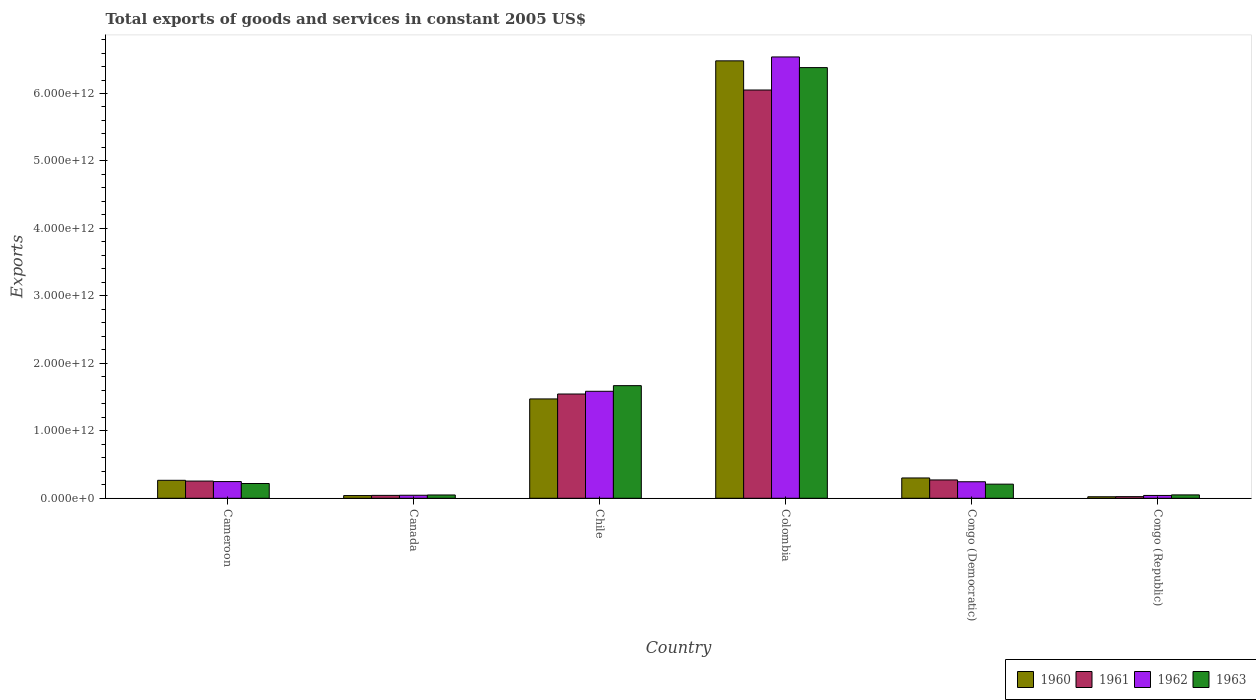Are the number of bars per tick equal to the number of legend labels?
Your answer should be compact. Yes. How many bars are there on the 4th tick from the left?
Keep it short and to the point. 4. What is the label of the 5th group of bars from the left?
Your answer should be very brief. Congo (Democratic). What is the total exports of goods and services in 1963 in Congo (Democratic)?
Offer a very short reply. 2.09e+11. Across all countries, what is the maximum total exports of goods and services in 1961?
Give a very brief answer. 6.05e+12. Across all countries, what is the minimum total exports of goods and services in 1962?
Offer a very short reply. 4.20e+1. In which country was the total exports of goods and services in 1961 minimum?
Keep it short and to the point. Congo (Republic). What is the total total exports of goods and services in 1962 in the graph?
Your response must be concise. 8.71e+12. What is the difference between the total exports of goods and services in 1962 in Cameroon and that in Chile?
Ensure brevity in your answer.  -1.34e+12. What is the difference between the total exports of goods and services in 1960 in Congo (Democratic) and the total exports of goods and services in 1962 in Cameroon?
Make the answer very short. 5.34e+1. What is the average total exports of goods and services in 1960 per country?
Keep it short and to the point. 1.43e+12. What is the difference between the total exports of goods and services of/in 1963 and total exports of goods and services of/in 1960 in Cameroon?
Give a very brief answer. -4.75e+1. What is the ratio of the total exports of goods and services in 1961 in Cameroon to that in Colombia?
Give a very brief answer. 0.04. Is the difference between the total exports of goods and services in 1963 in Cameroon and Congo (Republic) greater than the difference between the total exports of goods and services in 1960 in Cameroon and Congo (Republic)?
Make the answer very short. No. What is the difference between the highest and the second highest total exports of goods and services in 1960?
Keep it short and to the point. 6.18e+12. What is the difference between the highest and the lowest total exports of goods and services in 1962?
Make the answer very short. 6.50e+12. Is the sum of the total exports of goods and services in 1963 in Chile and Congo (Republic) greater than the maximum total exports of goods and services in 1962 across all countries?
Your answer should be very brief. No. Is it the case that in every country, the sum of the total exports of goods and services in 1962 and total exports of goods and services in 1960 is greater than the sum of total exports of goods and services in 1961 and total exports of goods and services in 1963?
Give a very brief answer. No. What does the 1st bar from the left in Cameroon represents?
Your response must be concise. 1960. Is it the case that in every country, the sum of the total exports of goods and services in 1962 and total exports of goods and services in 1960 is greater than the total exports of goods and services in 1963?
Ensure brevity in your answer.  Yes. How many bars are there?
Ensure brevity in your answer.  24. What is the difference between two consecutive major ticks on the Y-axis?
Provide a short and direct response. 1.00e+12. Are the values on the major ticks of Y-axis written in scientific E-notation?
Offer a terse response. Yes. Does the graph contain grids?
Provide a short and direct response. No. How many legend labels are there?
Your answer should be compact. 4. How are the legend labels stacked?
Offer a terse response. Horizontal. What is the title of the graph?
Offer a terse response. Total exports of goods and services in constant 2005 US$. What is the label or title of the X-axis?
Your answer should be compact. Country. What is the label or title of the Y-axis?
Ensure brevity in your answer.  Exports. What is the Exports in 1960 in Cameroon?
Your answer should be compact. 2.66e+11. What is the Exports of 1961 in Cameroon?
Your answer should be very brief. 2.55e+11. What is the Exports of 1962 in Cameroon?
Provide a short and direct response. 2.48e+11. What is the Exports in 1963 in Cameroon?
Give a very brief answer. 2.19e+11. What is the Exports of 1960 in Canada?
Keep it short and to the point. 4.02e+1. What is the Exports in 1961 in Canada?
Your response must be concise. 4.29e+1. What is the Exports of 1962 in Canada?
Offer a very short reply. 4.49e+1. What is the Exports in 1963 in Canada?
Give a very brief answer. 4.91e+1. What is the Exports of 1960 in Chile?
Give a very brief answer. 1.47e+12. What is the Exports of 1961 in Chile?
Keep it short and to the point. 1.55e+12. What is the Exports in 1962 in Chile?
Offer a very short reply. 1.59e+12. What is the Exports in 1963 in Chile?
Your answer should be very brief. 1.67e+12. What is the Exports of 1960 in Colombia?
Your answer should be compact. 6.48e+12. What is the Exports of 1961 in Colombia?
Make the answer very short. 6.05e+12. What is the Exports of 1962 in Colombia?
Offer a very short reply. 6.54e+12. What is the Exports of 1963 in Colombia?
Make the answer very short. 6.38e+12. What is the Exports of 1960 in Congo (Democratic)?
Give a very brief answer. 3.01e+11. What is the Exports of 1961 in Congo (Democratic)?
Provide a short and direct response. 2.72e+11. What is the Exports in 1962 in Congo (Democratic)?
Provide a short and direct response. 2.45e+11. What is the Exports of 1963 in Congo (Democratic)?
Ensure brevity in your answer.  2.09e+11. What is the Exports of 1960 in Congo (Republic)?
Provide a succinct answer. 2.25e+1. What is the Exports of 1961 in Congo (Republic)?
Your response must be concise. 2.42e+1. What is the Exports of 1962 in Congo (Republic)?
Keep it short and to the point. 4.20e+1. What is the Exports of 1963 in Congo (Republic)?
Ensure brevity in your answer.  5.01e+1. Across all countries, what is the maximum Exports in 1960?
Offer a terse response. 6.48e+12. Across all countries, what is the maximum Exports in 1961?
Offer a very short reply. 6.05e+12. Across all countries, what is the maximum Exports of 1962?
Make the answer very short. 6.54e+12. Across all countries, what is the maximum Exports of 1963?
Your response must be concise. 6.38e+12. Across all countries, what is the minimum Exports in 1960?
Ensure brevity in your answer.  2.25e+1. Across all countries, what is the minimum Exports in 1961?
Provide a succinct answer. 2.42e+1. Across all countries, what is the minimum Exports in 1962?
Provide a short and direct response. 4.20e+1. Across all countries, what is the minimum Exports in 1963?
Provide a succinct answer. 4.91e+1. What is the total Exports in 1960 in the graph?
Your response must be concise. 8.59e+12. What is the total Exports of 1961 in the graph?
Provide a short and direct response. 8.19e+12. What is the total Exports in 1962 in the graph?
Your response must be concise. 8.71e+12. What is the total Exports of 1963 in the graph?
Make the answer very short. 8.58e+12. What is the difference between the Exports in 1960 in Cameroon and that in Canada?
Your answer should be compact. 2.26e+11. What is the difference between the Exports in 1961 in Cameroon and that in Canada?
Provide a succinct answer. 2.12e+11. What is the difference between the Exports in 1962 in Cameroon and that in Canada?
Make the answer very short. 2.03e+11. What is the difference between the Exports in 1963 in Cameroon and that in Canada?
Ensure brevity in your answer.  1.70e+11. What is the difference between the Exports in 1960 in Cameroon and that in Chile?
Your response must be concise. -1.21e+12. What is the difference between the Exports in 1961 in Cameroon and that in Chile?
Keep it short and to the point. -1.29e+12. What is the difference between the Exports in 1962 in Cameroon and that in Chile?
Provide a succinct answer. -1.34e+12. What is the difference between the Exports in 1963 in Cameroon and that in Chile?
Provide a short and direct response. -1.45e+12. What is the difference between the Exports of 1960 in Cameroon and that in Colombia?
Offer a very short reply. -6.22e+12. What is the difference between the Exports of 1961 in Cameroon and that in Colombia?
Offer a terse response. -5.80e+12. What is the difference between the Exports of 1962 in Cameroon and that in Colombia?
Your answer should be compact. -6.29e+12. What is the difference between the Exports in 1963 in Cameroon and that in Colombia?
Offer a very short reply. -6.17e+12. What is the difference between the Exports in 1960 in Cameroon and that in Congo (Democratic)?
Keep it short and to the point. -3.46e+1. What is the difference between the Exports of 1961 in Cameroon and that in Congo (Democratic)?
Offer a very short reply. -1.66e+1. What is the difference between the Exports in 1962 in Cameroon and that in Congo (Democratic)?
Give a very brief answer. 2.67e+09. What is the difference between the Exports of 1963 in Cameroon and that in Congo (Democratic)?
Offer a terse response. 9.56e+09. What is the difference between the Exports of 1960 in Cameroon and that in Congo (Republic)?
Ensure brevity in your answer.  2.44e+11. What is the difference between the Exports of 1961 in Cameroon and that in Congo (Republic)?
Your response must be concise. 2.31e+11. What is the difference between the Exports of 1962 in Cameroon and that in Congo (Republic)?
Offer a very short reply. 2.06e+11. What is the difference between the Exports of 1963 in Cameroon and that in Congo (Republic)?
Your response must be concise. 1.69e+11. What is the difference between the Exports of 1960 in Canada and that in Chile?
Make the answer very short. -1.43e+12. What is the difference between the Exports of 1961 in Canada and that in Chile?
Your answer should be compact. -1.50e+12. What is the difference between the Exports in 1962 in Canada and that in Chile?
Ensure brevity in your answer.  -1.54e+12. What is the difference between the Exports in 1963 in Canada and that in Chile?
Keep it short and to the point. -1.62e+12. What is the difference between the Exports of 1960 in Canada and that in Colombia?
Make the answer very short. -6.44e+12. What is the difference between the Exports in 1961 in Canada and that in Colombia?
Provide a succinct answer. -6.01e+12. What is the difference between the Exports in 1962 in Canada and that in Colombia?
Provide a short and direct response. -6.50e+12. What is the difference between the Exports in 1963 in Canada and that in Colombia?
Offer a very short reply. -6.34e+12. What is the difference between the Exports in 1960 in Canada and that in Congo (Democratic)?
Your response must be concise. -2.61e+11. What is the difference between the Exports of 1961 in Canada and that in Congo (Democratic)?
Your answer should be compact. -2.29e+11. What is the difference between the Exports of 1962 in Canada and that in Congo (Democratic)?
Your answer should be very brief. -2.00e+11. What is the difference between the Exports in 1963 in Canada and that in Congo (Democratic)?
Provide a succinct answer. -1.60e+11. What is the difference between the Exports of 1960 in Canada and that in Congo (Republic)?
Give a very brief answer. 1.77e+1. What is the difference between the Exports in 1961 in Canada and that in Congo (Republic)?
Make the answer very short. 1.87e+1. What is the difference between the Exports in 1962 in Canada and that in Congo (Republic)?
Offer a very short reply. 2.86e+09. What is the difference between the Exports of 1963 in Canada and that in Congo (Republic)?
Make the answer very short. -1.07e+09. What is the difference between the Exports of 1960 in Chile and that in Colombia?
Provide a succinct answer. -5.01e+12. What is the difference between the Exports of 1961 in Chile and that in Colombia?
Offer a terse response. -4.51e+12. What is the difference between the Exports of 1962 in Chile and that in Colombia?
Offer a very short reply. -4.96e+12. What is the difference between the Exports in 1963 in Chile and that in Colombia?
Give a very brief answer. -4.71e+12. What is the difference between the Exports of 1960 in Chile and that in Congo (Democratic)?
Offer a very short reply. 1.17e+12. What is the difference between the Exports in 1961 in Chile and that in Congo (Democratic)?
Your answer should be compact. 1.27e+12. What is the difference between the Exports of 1962 in Chile and that in Congo (Democratic)?
Your answer should be compact. 1.34e+12. What is the difference between the Exports of 1963 in Chile and that in Congo (Democratic)?
Give a very brief answer. 1.46e+12. What is the difference between the Exports of 1960 in Chile and that in Congo (Republic)?
Ensure brevity in your answer.  1.45e+12. What is the difference between the Exports in 1961 in Chile and that in Congo (Republic)?
Your answer should be compact. 1.52e+12. What is the difference between the Exports in 1962 in Chile and that in Congo (Republic)?
Offer a very short reply. 1.54e+12. What is the difference between the Exports in 1963 in Chile and that in Congo (Republic)?
Provide a succinct answer. 1.62e+12. What is the difference between the Exports in 1960 in Colombia and that in Congo (Democratic)?
Ensure brevity in your answer.  6.18e+12. What is the difference between the Exports in 1961 in Colombia and that in Congo (Democratic)?
Offer a terse response. 5.78e+12. What is the difference between the Exports in 1962 in Colombia and that in Congo (Democratic)?
Offer a very short reply. 6.30e+12. What is the difference between the Exports in 1963 in Colombia and that in Congo (Democratic)?
Provide a succinct answer. 6.17e+12. What is the difference between the Exports in 1960 in Colombia and that in Congo (Republic)?
Give a very brief answer. 6.46e+12. What is the difference between the Exports of 1961 in Colombia and that in Congo (Republic)?
Provide a succinct answer. 6.03e+12. What is the difference between the Exports in 1962 in Colombia and that in Congo (Republic)?
Offer a very short reply. 6.50e+12. What is the difference between the Exports in 1963 in Colombia and that in Congo (Republic)?
Keep it short and to the point. 6.33e+12. What is the difference between the Exports of 1960 in Congo (Democratic) and that in Congo (Republic)?
Ensure brevity in your answer.  2.79e+11. What is the difference between the Exports in 1961 in Congo (Democratic) and that in Congo (Republic)?
Your response must be concise. 2.48e+11. What is the difference between the Exports in 1962 in Congo (Democratic) and that in Congo (Republic)?
Offer a terse response. 2.03e+11. What is the difference between the Exports of 1963 in Congo (Democratic) and that in Congo (Republic)?
Ensure brevity in your answer.  1.59e+11. What is the difference between the Exports of 1960 in Cameroon and the Exports of 1961 in Canada?
Give a very brief answer. 2.24e+11. What is the difference between the Exports in 1960 in Cameroon and the Exports in 1962 in Canada?
Offer a terse response. 2.22e+11. What is the difference between the Exports in 1960 in Cameroon and the Exports in 1963 in Canada?
Offer a terse response. 2.17e+11. What is the difference between the Exports of 1961 in Cameroon and the Exports of 1962 in Canada?
Offer a terse response. 2.10e+11. What is the difference between the Exports of 1961 in Cameroon and the Exports of 1963 in Canada?
Ensure brevity in your answer.  2.06e+11. What is the difference between the Exports in 1962 in Cameroon and the Exports in 1963 in Canada?
Ensure brevity in your answer.  1.99e+11. What is the difference between the Exports in 1960 in Cameroon and the Exports in 1961 in Chile?
Keep it short and to the point. -1.28e+12. What is the difference between the Exports of 1960 in Cameroon and the Exports of 1962 in Chile?
Your answer should be very brief. -1.32e+12. What is the difference between the Exports in 1960 in Cameroon and the Exports in 1963 in Chile?
Your response must be concise. -1.40e+12. What is the difference between the Exports in 1961 in Cameroon and the Exports in 1962 in Chile?
Give a very brief answer. -1.33e+12. What is the difference between the Exports of 1961 in Cameroon and the Exports of 1963 in Chile?
Offer a very short reply. -1.41e+12. What is the difference between the Exports of 1962 in Cameroon and the Exports of 1963 in Chile?
Make the answer very short. -1.42e+12. What is the difference between the Exports of 1960 in Cameroon and the Exports of 1961 in Colombia?
Your response must be concise. -5.79e+12. What is the difference between the Exports in 1960 in Cameroon and the Exports in 1962 in Colombia?
Provide a succinct answer. -6.28e+12. What is the difference between the Exports of 1960 in Cameroon and the Exports of 1963 in Colombia?
Your response must be concise. -6.12e+12. What is the difference between the Exports of 1961 in Cameroon and the Exports of 1962 in Colombia?
Provide a short and direct response. -6.29e+12. What is the difference between the Exports in 1961 in Cameroon and the Exports in 1963 in Colombia?
Provide a succinct answer. -6.13e+12. What is the difference between the Exports in 1962 in Cameroon and the Exports in 1963 in Colombia?
Offer a terse response. -6.14e+12. What is the difference between the Exports in 1960 in Cameroon and the Exports in 1961 in Congo (Democratic)?
Provide a succinct answer. -5.27e+09. What is the difference between the Exports of 1960 in Cameroon and the Exports of 1962 in Congo (Democratic)?
Your response must be concise. 2.15e+1. What is the difference between the Exports in 1960 in Cameroon and the Exports in 1963 in Congo (Democratic)?
Your answer should be very brief. 5.70e+1. What is the difference between the Exports of 1961 in Cameroon and the Exports of 1962 in Congo (Democratic)?
Make the answer very short. 1.01e+1. What is the difference between the Exports of 1961 in Cameroon and the Exports of 1963 in Congo (Democratic)?
Make the answer very short. 4.57e+1. What is the difference between the Exports in 1962 in Cameroon and the Exports in 1963 in Congo (Democratic)?
Give a very brief answer. 3.83e+1. What is the difference between the Exports in 1960 in Cameroon and the Exports in 1961 in Congo (Republic)?
Offer a terse response. 2.42e+11. What is the difference between the Exports in 1960 in Cameroon and the Exports in 1962 in Congo (Republic)?
Ensure brevity in your answer.  2.24e+11. What is the difference between the Exports in 1960 in Cameroon and the Exports in 1963 in Congo (Republic)?
Provide a short and direct response. 2.16e+11. What is the difference between the Exports in 1961 in Cameroon and the Exports in 1962 in Congo (Republic)?
Offer a terse response. 2.13e+11. What is the difference between the Exports of 1961 in Cameroon and the Exports of 1963 in Congo (Republic)?
Offer a terse response. 2.05e+11. What is the difference between the Exports of 1962 in Cameroon and the Exports of 1963 in Congo (Republic)?
Make the answer very short. 1.98e+11. What is the difference between the Exports in 1960 in Canada and the Exports in 1961 in Chile?
Make the answer very short. -1.51e+12. What is the difference between the Exports of 1960 in Canada and the Exports of 1962 in Chile?
Your response must be concise. -1.55e+12. What is the difference between the Exports in 1960 in Canada and the Exports in 1963 in Chile?
Provide a short and direct response. -1.63e+12. What is the difference between the Exports in 1961 in Canada and the Exports in 1962 in Chile?
Provide a short and direct response. -1.54e+12. What is the difference between the Exports in 1961 in Canada and the Exports in 1963 in Chile?
Offer a very short reply. -1.63e+12. What is the difference between the Exports in 1962 in Canada and the Exports in 1963 in Chile?
Ensure brevity in your answer.  -1.62e+12. What is the difference between the Exports of 1960 in Canada and the Exports of 1961 in Colombia?
Keep it short and to the point. -6.01e+12. What is the difference between the Exports of 1960 in Canada and the Exports of 1962 in Colombia?
Provide a short and direct response. -6.50e+12. What is the difference between the Exports in 1960 in Canada and the Exports in 1963 in Colombia?
Make the answer very short. -6.34e+12. What is the difference between the Exports in 1961 in Canada and the Exports in 1962 in Colombia?
Keep it short and to the point. -6.50e+12. What is the difference between the Exports of 1961 in Canada and the Exports of 1963 in Colombia?
Offer a terse response. -6.34e+12. What is the difference between the Exports in 1962 in Canada and the Exports in 1963 in Colombia?
Provide a succinct answer. -6.34e+12. What is the difference between the Exports in 1960 in Canada and the Exports in 1961 in Congo (Democratic)?
Offer a terse response. -2.32e+11. What is the difference between the Exports in 1960 in Canada and the Exports in 1962 in Congo (Democratic)?
Your answer should be compact. -2.05e+11. What is the difference between the Exports in 1960 in Canada and the Exports in 1963 in Congo (Democratic)?
Make the answer very short. -1.69e+11. What is the difference between the Exports of 1961 in Canada and the Exports of 1962 in Congo (Democratic)?
Offer a terse response. -2.02e+11. What is the difference between the Exports in 1961 in Canada and the Exports in 1963 in Congo (Democratic)?
Keep it short and to the point. -1.67e+11. What is the difference between the Exports of 1962 in Canada and the Exports of 1963 in Congo (Democratic)?
Give a very brief answer. -1.65e+11. What is the difference between the Exports of 1960 in Canada and the Exports of 1961 in Congo (Republic)?
Give a very brief answer. 1.60e+1. What is the difference between the Exports in 1960 in Canada and the Exports in 1962 in Congo (Republic)?
Your answer should be very brief. -1.85e+09. What is the difference between the Exports of 1960 in Canada and the Exports of 1963 in Congo (Republic)?
Your answer should be very brief. -9.92e+09. What is the difference between the Exports in 1961 in Canada and the Exports in 1962 in Congo (Republic)?
Ensure brevity in your answer.  8.81e+08. What is the difference between the Exports of 1961 in Canada and the Exports of 1963 in Congo (Republic)?
Provide a succinct answer. -7.19e+09. What is the difference between the Exports of 1962 in Canada and the Exports of 1963 in Congo (Republic)?
Give a very brief answer. -5.21e+09. What is the difference between the Exports in 1960 in Chile and the Exports in 1961 in Colombia?
Offer a terse response. -4.58e+12. What is the difference between the Exports in 1960 in Chile and the Exports in 1962 in Colombia?
Keep it short and to the point. -5.07e+12. What is the difference between the Exports in 1960 in Chile and the Exports in 1963 in Colombia?
Ensure brevity in your answer.  -4.91e+12. What is the difference between the Exports in 1961 in Chile and the Exports in 1962 in Colombia?
Make the answer very short. -5.00e+12. What is the difference between the Exports of 1961 in Chile and the Exports of 1963 in Colombia?
Ensure brevity in your answer.  -4.84e+12. What is the difference between the Exports in 1962 in Chile and the Exports in 1963 in Colombia?
Make the answer very short. -4.80e+12. What is the difference between the Exports in 1960 in Chile and the Exports in 1961 in Congo (Democratic)?
Give a very brief answer. 1.20e+12. What is the difference between the Exports of 1960 in Chile and the Exports of 1962 in Congo (Democratic)?
Make the answer very short. 1.23e+12. What is the difference between the Exports of 1960 in Chile and the Exports of 1963 in Congo (Democratic)?
Ensure brevity in your answer.  1.26e+12. What is the difference between the Exports of 1961 in Chile and the Exports of 1962 in Congo (Democratic)?
Provide a short and direct response. 1.30e+12. What is the difference between the Exports in 1961 in Chile and the Exports in 1963 in Congo (Democratic)?
Make the answer very short. 1.34e+12. What is the difference between the Exports in 1962 in Chile and the Exports in 1963 in Congo (Democratic)?
Give a very brief answer. 1.38e+12. What is the difference between the Exports in 1960 in Chile and the Exports in 1961 in Congo (Republic)?
Offer a terse response. 1.45e+12. What is the difference between the Exports in 1960 in Chile and the Exports in 1962 in Congo (Republic)?
Your answer should be compact. 1.43e+12. What is the difference between the Exports of 1960 in Chile and the Exports of 1963 in Congo (Republic)?
Keep it short and to the point. 1.42e+12. What is the difference between the Exports of 1961 in Chile and the Exports of 1962 in Congo (Republic)?
Provide a short and direct response. 1.50e+12. What is the difference between the Exports in 1961 in Chile and the Exports in 1963 in Congo (Republic)?
Your answer should be very brief. 1.50e+12. What is the difference between the Exports of 1962 in Chile and the Exports of 1963 in Congo (Republic)?
Provide a short and direct response. 1.54e+12. What is the difference between the Exports in 1960 in Colombia and the Exports in 1961 in Congo (Democratic)?
Offer a very short reply. 6.21e+12. What is the difference between the Exports of 1960 in Colombia and the Exports of 1962 in Congo (Democratic)?
Keep it short and to the point. 6.24e+12. What is the difference between the Exports in 1960 in Colombia and the Exports in 1963 in Congo (Democratic)?
Your answer should be compact. 6.27e+12. What is the difference between the Exports in 1961 in Colombia and the Exports in 1962 in Congo (Democratic)?
Your answer should be very brief. 5.81e+12. What is the difference between the Exports in 1961 in Colombia and the Exports in 1963 in Congo (Democratic)?
Ensure brevity in your answer.  5.84e+12. What is the difference between the Exports of 1962 in Colombia and the Exports of 1963 in Congo (Democratic)?
Offer a very short reply. 6.33e+12. What is the difference between the Exports of 1960 in Colombia and the Exports of 1961 in Congo (Republic)?
Your answer should be compact. 6.46e+12. What is the difference between the Exports in 1960 in Colombia and the Exports in 1962 in Congo (Republic)?
Your response must be concise. 6.44e+12. What is the difference between the Exports in 1960 in Colombia and the Exports in 1963 in Congo (Republic)?
Your answer should be very brief. 6.43e+12. What is the difference between the Exports in 1961 in Colombia and the Exports in 1962 in Congo (Republic)?
Provide a short and direct response. 6.01e+12. What is the difference between the Exports of 1961 in Colombia and the Exports of 1963 in Congo (Republic)?
Your answer should be very brief. 6.00e+12. What is the difference between the Exports of 1962 in Colombia and the Exports of 1963 in Congo (Republic)?
Give a very brief answer. 6.49e+12. What is the difference between the Exports in 1960 in Congo (Democratic) and the Exports in 1961 in Congo (Republic)?
Make the answer very short. 2.77e+11. What is the difference between the Exports in 1960 in Congo (Democratic) and the Exports in 1962 in Congo (Republic)?
Offer a very short reply. 2.59e+11. What is the difference between the Exports in 1960 in Congo (Democratic) and the Exports in 1963 in Congo (Republic)?
Your response must be concise. 2.51e+11. What is the difference between the Exports of 1961 in Congo (Democratic) and the Exports of 1962 in Congo (Republic)?
Give a very brief answer. 2.30e+11. What is the difference between the Exports in 1961 in Congo (Democratic) and the Exports in 1963 in Congo (Republic)?
Your answer should be compact. 2.22e+11. What is the difference between the Exports in 1962 in Congo (Democratic) and the Exports in 1963 in Congo (Republic)?
Offer a terse response. 1.95e+11. What is the average Exports of 1960 per country?
Ensure brevity in your answer.  1.43e+12. What is the average Exports in 1961 per country?
Provide a succinct answer. 1.37e+12. What is the average Exports in 1962 per country?
Offer a terse response. 1.45e+12. What is the average Exports of 1963 per country?
Your response must be concise. 1.43e+12. What is the difference between the Exports of 1960 and Exports of 1961 in Cameroon?
Provide a succinct answer. 1.14e+1. What is the difference between the Exports in 1960 and Exports in 1962 in Cameroon?
Your answer should be compact. 1.88e+1. What is the difference between the Exports in 1960 and Exports in 1963 in Cameroon?
Give a very brief answer. 4.75e+1. What is the difference between the Exports of 1961 and Exports of 1962 in Cameroon?
Your answer should be very brief. 7.43e+09. What is the difference between the Exports in 1961 and Exports in 1963 in Cameroon?
Keep it short and to the point. 3.61e+1. What is the difference between the Exports in 1962 and Exports in 1963 in Cameroon?
Your answer should be compact. 2.87e+1. What is the difference between the Exports of 1960 and Exports of 1961 in Canada?
Keep it short and to the point. -2.73e+09. What is the difference between the Exports of 1960 and Exports of 1962 in Canada?
Make the answer very short. -4.72e+09. What is the difference between the Exports of 1960 and Exports of 1963 in Canada?
Make the answer very short. -8.86e+09. What is the difference between the Exports in 1961 and Exports in 1962 in Canada?
Offer a very short reply. -1.98e+09. What is the difference between the Exports in 1961 and Exports in 1963 in Canada?
Offer a terse response. -6.12e+09. What is the difference between the Exports in 1962 and Exports in 1963 in Canada?
Your response must be concise. -4.14e+09. What is the difference between the Exports of 1960 and Exports of 1961 in Chile?
Provide a succinct answer. -7.28e+1. What is the difference between the Exports in 1960 and Exports in 1962 in Chile?
Provide a short and direct response. -1.13e+11. What is the difference between the Exports of 1960 and Exports of 1963 in Chile?
Your response must be concise. -1.97e+11. What is the difference between the Exports of 1961 and Exports of 1962 in Chile?
Your response must be concise. -4.03e+1. What is the difference between the Exports of 1961 and Exports of 1963 in Chile?
Your answer should be compact. -1.24e+11. What is the difference between the Exports of 1962 and Exports of 1963 in Chile?
Offer a terse response. -8.37e+1. What is the difference between the Exports of 1960 and Exports of 1961 in Colombia?
Your response must be concise. 4.32e+11. What is the difference between the Exports of 1960 and Exports of 1962 in Colombia?
Offer a terse response. -5.79e+1. What is the difference between the Exports of 1960 and Exports of 1963 in Colombia?
Keep it short and to the point. 1.00e+11. What is the difference between the Exports in 1961 and Exports in 1962 in Colombia?
Offer a terse response. -4.90e+11. What is the difference between the Exports in 1961 and Exports in 1963 in Colombia?
Your answer should be compact. -3.32e+11. What is the difference between the Exports of 1962 and Exports of 1963 in Colombia?
Provide a succinct answer. 1.58e+11. What is the difference between the Exports in 1960 and Exports in 1961 in Congo (Democratic)?
Give a very brief answer. 2.94e+1. What is the difference between the Exports of 1960 and Exports of 1962 in Congo (Democratic)?
Make the answer very short. 5.61e+1. What is the difference between the Exports in 1960 and Exports in 1963 in Congo (Democratic)?
Your answer should be very brief. 9.17e+1. What is the difference between the Exports of 1961 and Exports of 1962 in Congo (Democratic)?
Offer a terse response. 2.67e+1. What is the difference between the Exports of 1961 and Exports of 1963 in Congo (Democratic)?
Give a very brief answer. 6.23e+1. What is the difference between the Exports in 1962 and Exports in 1963 in Congo (Democratic)?
Make the answer very short. 3.56e+1. What is the difference between the Exports in 1960 and Exports in 1961 in Congo (Republic)?
Provide a short and direct response. -1.69e+09. What is the difference between the Exports in 1960 and Exports in 1962 in Congo (Republic)?
Ensure brevity in your answer.  -1.95e+1. What is the difference between the Exports in 1960 and Exports in 1963 in Congo (Republic)?
Your response must be concise. -2.76e+1. What is the difference between the Exports in 1961 and Exports in 1962 in Congo (Republic)?
Give a very brief answer. -1.78e+1. What is the difference between the Exports in 1961 and Exports in 1963 in Congo (Republic)?
Provide a succinct answer. -2.59e+1. What is the difference between the Exports in 1962 and Exports in 1963 in Congo (Republic)?
Your response must be concise. -8.07e+09. What is the ratio of the Exports in 1960 in Cameroon to that in Canada?
Make the answer very short. 6.63. What is the ratio of the Exports in 1961 in Cameroon to that in Canada?
Make the answer very short. 5.94. What is the ratio of the Exports in 1962 in Cameroon to that in Canada?
Give a very brief answer. 5.51. What is the ratio of the Exports of 1963 in Cameroon to that in Canada?
Keep it short and to the point. 4.46. What is the ratio of the Exports of 1960 in Cameroon to that in Chile?
Keep it short and to the point. 0.18. What is the ratio of the Exports of 1961 in Cameroon to that in Chile?
Your response must be concise. 0.17. What is the ratio of the Exports in 1962 in Cameroon to that in Chile?
Offer a very short reply. 0.16. What is the ratio of the Exports in 1963 in Cameroon to that in Chile?
Your response must be concise. 0.13. What is the ratio of the Exports in 1960 in Cameroon to that in Colombia?
Provide a short and direct response. 0.04. What is the ratio of the Exports in 1961 in Cameroon to that in Colombia?
Ensure brevity in your answer.  0.04. What is the ratio of the Exports in 1962 in Cameroon to that in Colombia?
Make the answer very short. 0.04. What is the ratio of the Exports of 1963 in Cameroon to that in Colombia?
Offer a very short reply. 0.03. What is the ratio of the Exports in 1960 in Cameroon to that in Congo (Democratic)?
Your response must be concise. 0.88. What is the ratio of the Exports in 1961 in Cameroon to that in Congo (Democratic)?
Keep it short and to the point. 0.94. What is the ratio of the Exports of 1962 in Cameroon to that in Congo (Democratic)?
Your answer should be very brief. 1.01. What is the ratio of the Exports of 1963 in Cameroon to that in Congo (Democratic)?
Provide a succinct answer. 1.05. What is the ratio of the Exports of 1960 in Cameroon to that in Congo (Republic)?
Keep it short and to the point. 11.83. What is the ratio of the Exports in 1961 in Cameroon to that in Congo (Republic)?
Your answer should be very brief. 10.54. What is the ratio of the Exports in 1962 in Cameroon to that in Congo (Republic)?
Make the answer very short. 5.89. What is the ratio of the Exports in 1963 in Cameroon to that in Congo (Republic)?
Give a very brief answer. 4.37. What is the ratio of the Exports of 1960 in Canada to that in Chile?
Your answer should be very brief. 0.03. What is the ratio of the Exports of 1961 in Canada to that in Chile?
Your answer should be compact. 0.03. What is the ratio of the Exports of 1962 in Canada to that in Chile?
Provide a short and direct response. 0.03. What is the ratio of the Exports of 1963 in Canada to that in Chile?
Make the answer very short. 0.03. What is the ratio of the Exports of 1960 in Canada to that in Colombia?
Your answer should be very brief. 0.01. What is the ratio of the Exports of 1961 in Canada to that in Colombia?
Give a very brief answer. 0.01. What is the ratio of the Exports in 1962 in Canada to that in Colombia?
Your answer should be compact. 0.01. What is the ratio of the Exports in 1963 in Canada to that in Colombia?
Offer a very short reply. 0.01. What is the ratio of the Exports of 1960 in Canada to that in Congo (Democratic)?
Provide a succinct answer. 0.13. What is the ratio of the Exports in 1961 in Canada to that in Congo (Democratic)?
Provide a succinct answer. 0.16. What is the ratio of the Exports of 1962 in Canada to that in Congo (Democratic)?
Provide a short and direct response. 0.18. What is the ratio of the Exports of 1963 in Canada to that in Congo (Democratic)?
Offer a very short reply. 0.23. What is the ratio of the Exports of 1960 in Canada to that in Congo (Republic)?
Ensure brevity in your answer.  1.78. What is the ratio of the Exports of 1961 in Canada to that in Congo (Republic)?
Offer a very short reply. 1.77. What is the ratio of the Exports of 1962 in Canada to that in Congo (Republic)?
Provide a succinct answer. 1.07. What is the ratio of the Exports in 1963 in Canada to that in Congo (Republic)?
Keep it short and to the point. 0.98. What is the ratio of the Exports in 1960 in Chile to that in Colombia?
Your answer should be very brief. 0.23. What is the ratio of the Exports of 1961 in Chile to that in Colombia?
Provide a succinct answer. 0.26. What is the ratio of the Exports in 1962 in Chile to that in Colombia?
Keep it short and to the point. 0.24. What is the ratio of the Exports in 1963 in Chile to that in Colombia?
Offer a terse response. 0.26. What is the ratio of the Exports in 1960 in Chile to that in Congo (Democratic)?
Make the answer very short. 4.89. What is the ratio of the Exports of 1961 in Chile to that in Congo (Democratic)?
Your response must be concise. 5.69. What is the ratio of the Exports in 1962 in Chile to that in Congo (Democratic)?
Keep it short and to the point. 6.47. What is the ratio of the Exports in 1963 in Chile to that in Congo (Democratic)?
Give a very brief answer. 7.97. What is the ratio of the Exports in 1960 in Chile to that in Congo (Republic)?
Provide a succinct answer. 65.38. What is the ratio of the Exports of 1961 in Chile to that in Congo (Republic)?
Your answer should be compact. 63.82. What is the ratio of the Exports in 1962 in Chile to that in Congo (Republic)?
Provide a succinct answer. 37.72. What is the ratio of the Exports in 1963 in Chile to that in Congo (Republic)?
Ensure brevity in your answer.  33.31. What is the ratio of the Exports in 1960 in Colombia to that in Congo (Democratic)?
Ensure brevity in your answer.  21.53. What is the ratio of the Exports in 1961 in Colombia to that in Congo (Democratic)?
Keep it short and to the point. 22.27. What is the ratio of the Exports in 1962 in Colombia to that in Congo (Democratic)?
Keep it short and to the point. 26.7. What is the ratio of the Exports in 1963 in Colombia to that in Congo (Democratic)?
Provide a succinct answer. 30.48. What is the ratio of the Exports of 1960 in Colombia to that in Congo (Republic)?
Ensure brevity in your answer.  287.84. What is the ratio of the Exports of 1961 in Colombia to that in Congo (Republic)?
Your answer should be compact. 249.91. What is the ratio of the Exports of 1962 in Colombia to that in Congo (Republic)?
Give a very brief answer. 155.58. What is the ratio of the Exports of 1963 in Colombia to that in Congo (Republic)?
Give a very brief answer. 127.37. What is the ratio of the Exports in 1960 in Congo (Democratic) to that in Congo (Republic)?
Your answer should be very brief. 13.37. What is the ratio of the Exports in 1961 in Congo (Democratic) to that in Congo (Republic)?
Give a very brief answer. 11.22. What is the ratio of the Exports of 1962 in Congo (Democratic) to that in Congo (Republic)?
Ensure brevity in your answer.  5.83. What is the ratio of the Exports of 1963 in Congo (Democratic) to that in Congo (Republic)?
Your response must be concise. 4.18. What is the difference between the highest and the second highest Exports of 1960?
Provide a short and direct response. 5.01e+12. What is the difference between the highest and the second highest Exports in 1961?
Ensure brevity in your answer.  4.51e+12. What is the difference between the highest and the second highest Exports in 1962?
Offer a very short reply. 4.96e+12. What is the difference between the highest and the second highest Exports in 1963?
Your answer should be very brief. 4.71e+12. What is the difference between the highest and the lowest Exports in 1960?
Your answer should be compact. 6.46e+12. What is the difference between the highest and the lowest Exports of 1961?
Offer a terse response. 6.03e+12. What is the difference between the highest and the lowest Exports of 1962?
Make the answer very short. 6.50e+12. What is the difference between the highest and the lowest Exports in 1963?
Ensure brevity in your answer.  6.34e+12. 